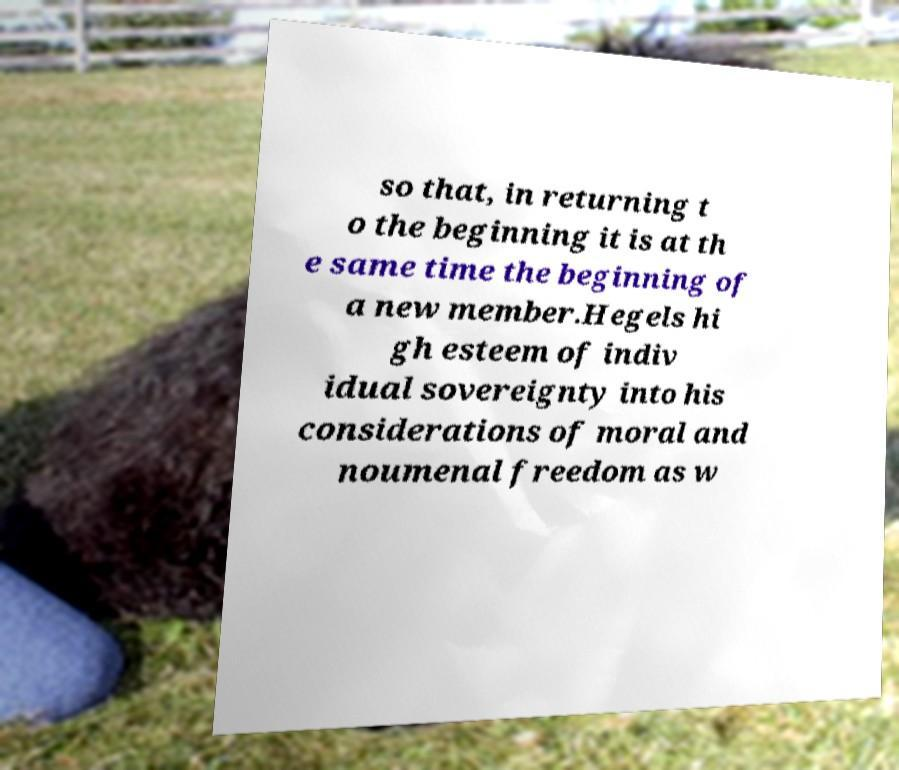What messages or text are displayed in this image? I need them in a readable, typed format. so that, in returning t o the beginning it is at th e same time the beginning of a new member.Hegels hi gh esteem of indiv idual sovereignty into his considerations of moral and noumenal freedom as w 